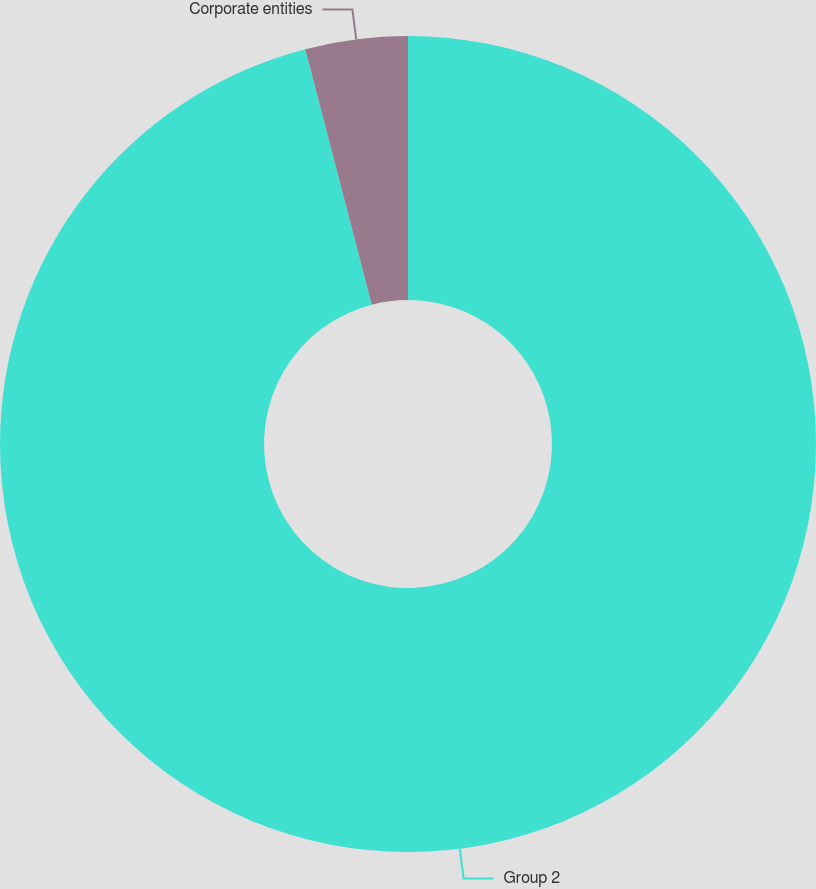Convert chart. <chart><loc_0><loc_0><loc_500><loc_500><pie_chart><fcel>Group 2<fcel>Corporate entities<nl><fcel>95.95%<fcel>4.05%<nl></chart> 